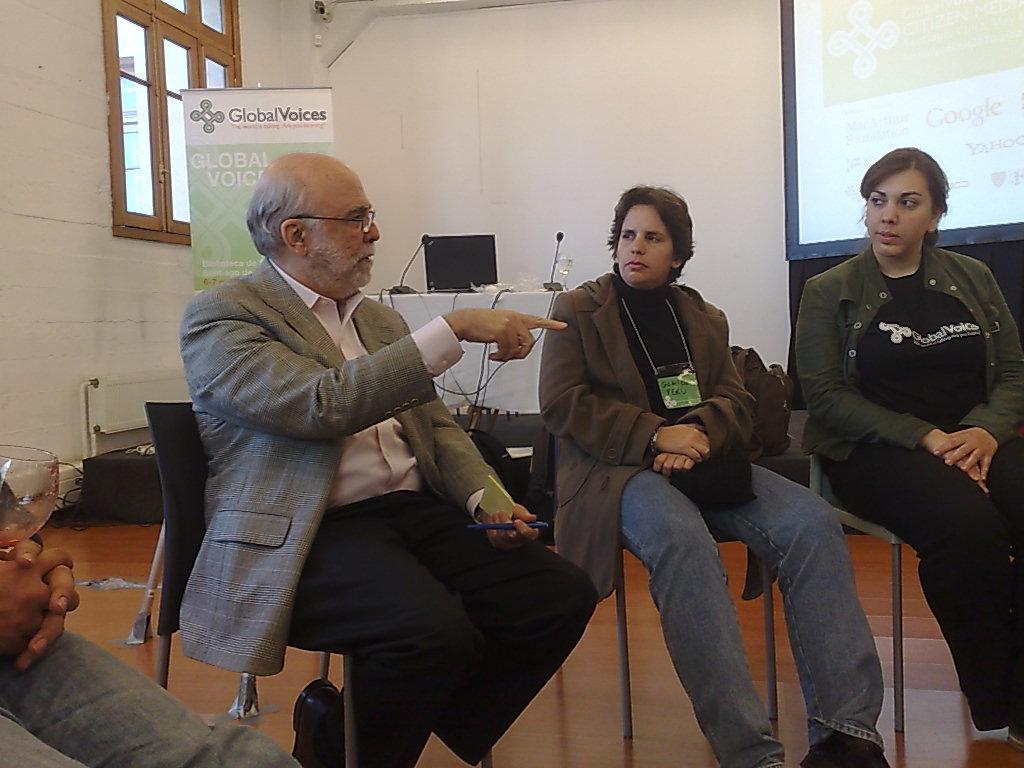Describe this image in one or two sentences. In this image we can see persons sitting on the chairs. In the background we can see an advertisement, table, laptop, mics, glass tumbler, screen, window and wall. 